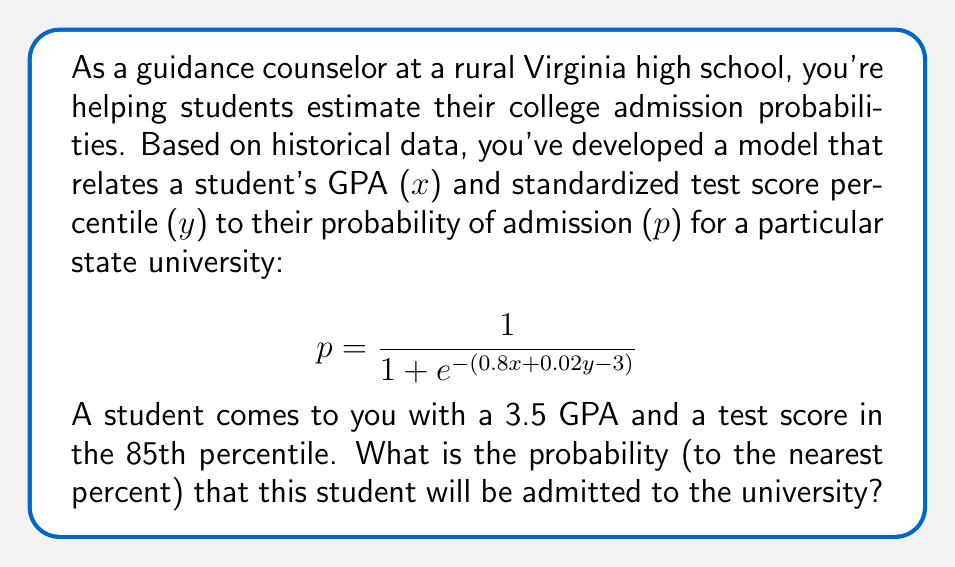Solve this math problem. Let's approach this step-by-step:

1) We have the logistic regression model for admission probability:
   $$p = \frac{1}{1 + e^{-(0.8x + 0.02y - 3)}}$$

2) We need to substitute the values:
   $x = 3.5$ (GPA)
   $y = 85$ (test score percentile)

3) Let's calculate the exponent first:
   $0.8x + 0.02y - 3$
   $= 0.8(3.5) + 0.02(85) - 3$
   $= 2.8 + 1.7 - 3$
   $= 1.5$

4) Now we can calculate the probability:
   $$p = \frac{1}{1 + e^{-1.5}}$$

5) Using a calculator (or computer):
   $e^{-1.5} \approx 0.2231$
   
   $$p = \frac{1}{1 + 0.2231} \approx 0.8176$$

6) Converting to a percentage and rounding to the nearest percent:
   $0.8176 * 100\% \approx 82\%$

Therefore, the student has approximately an 82% chance of being admitted to the university.
Answer: 82% 